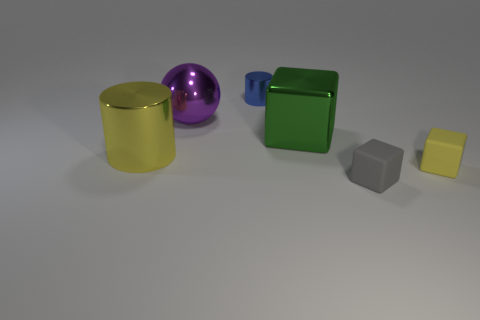What materials do the objects appear to be made from? The yellow and green objects exhibit a matte finish, indicating they might be made of a plastic-like material with a non-reflective surface. The purple object has a reflective metallic surface, and the grey block appears to have a slightly textured surface suggesting it could be made of stone or concrete. 